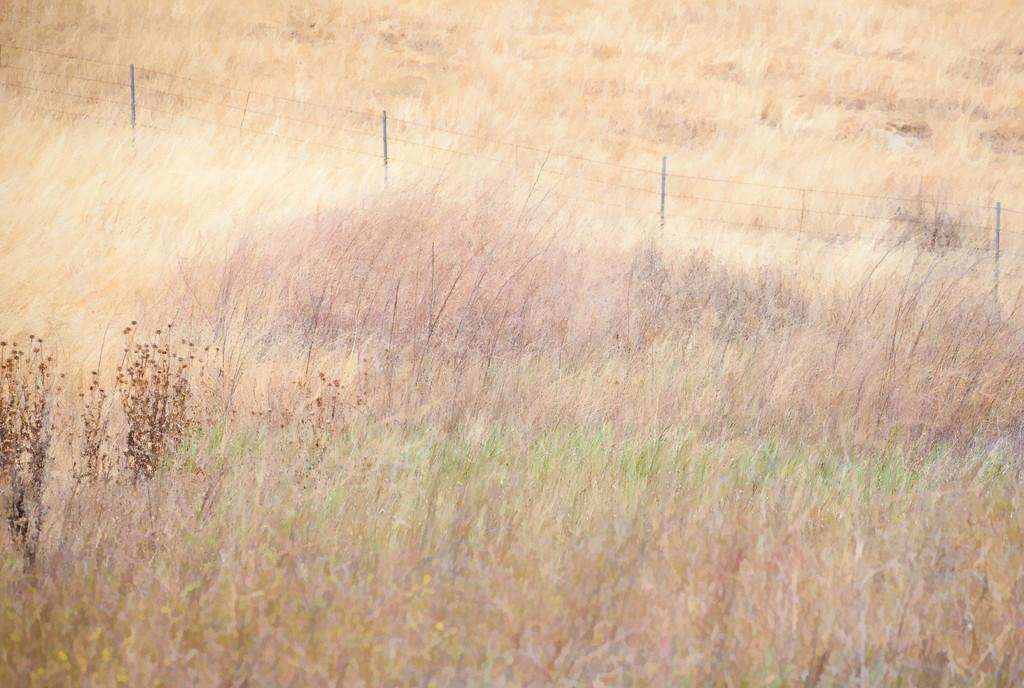What type of structure can be seen in the image? There is fencing in the image. What type of vegetation is present in the image? There are plants and grass in the image. How many books are stacked on the self in the image? There is no self or books present in the image; it features fencing, plants, and grass. 